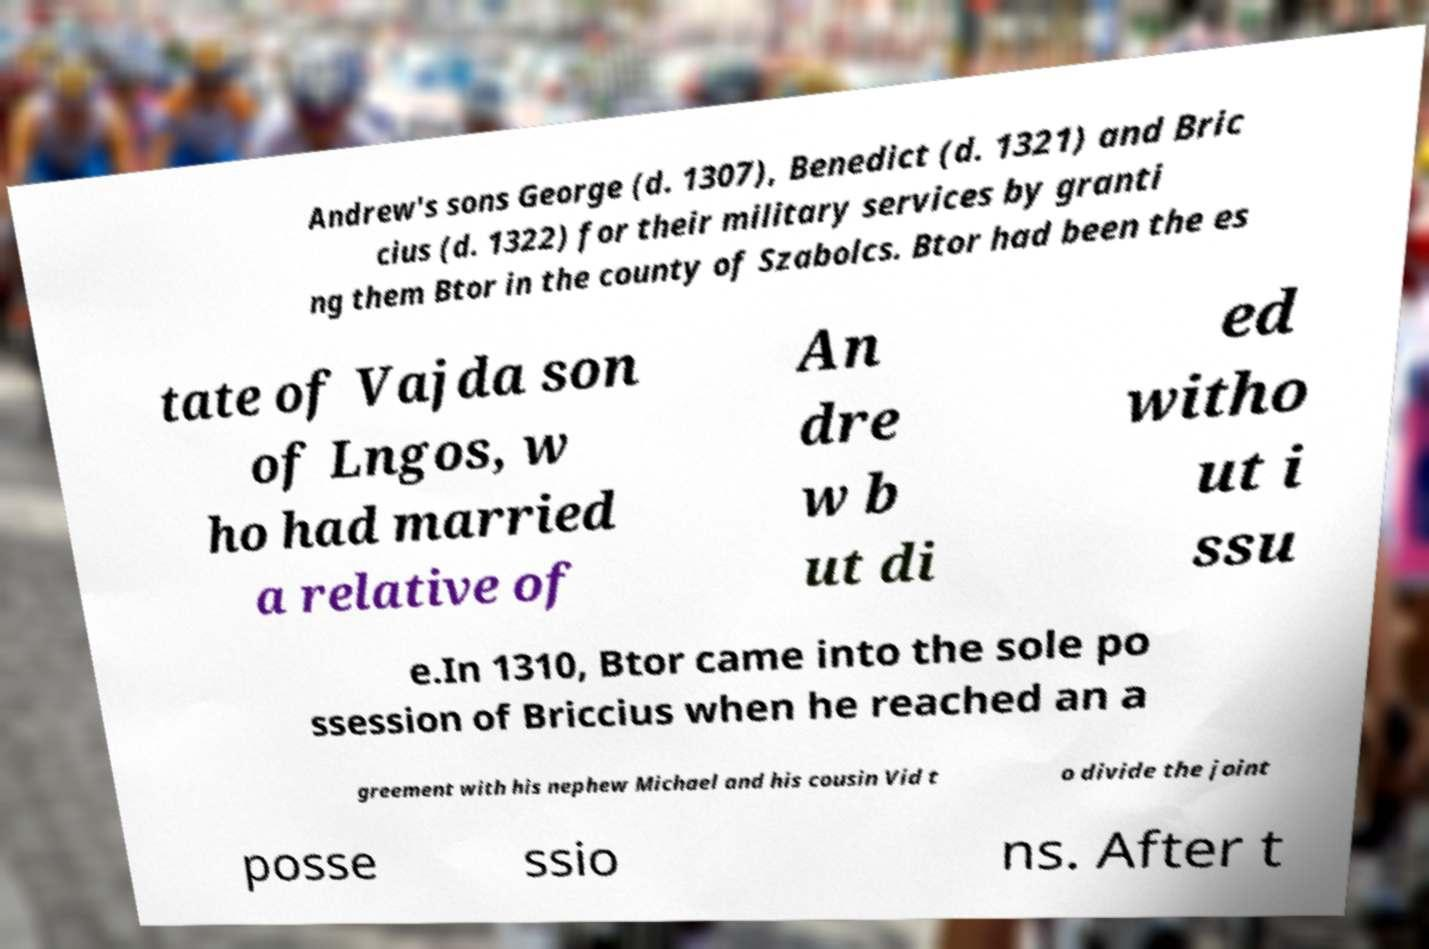For documentation purposes, I need the text within this image transcribed. Could you provide that? Andrew's sons George (d. 1307), Benedict (d. 1321) and Bric cius (d. 1322) for their military services by granti ng them Btor in the county of Szabolcs. Btor had been the es tate of Vajda son of Lngos, w ho had married a relative of An dre w b ut di ed witho ut i ssu e.In 1310, Btor came into the sole po ssession of Briccius when he reached an a greement with his nephew Michael and his cousin Vid t o divide the joint posse ssio ns. After t 